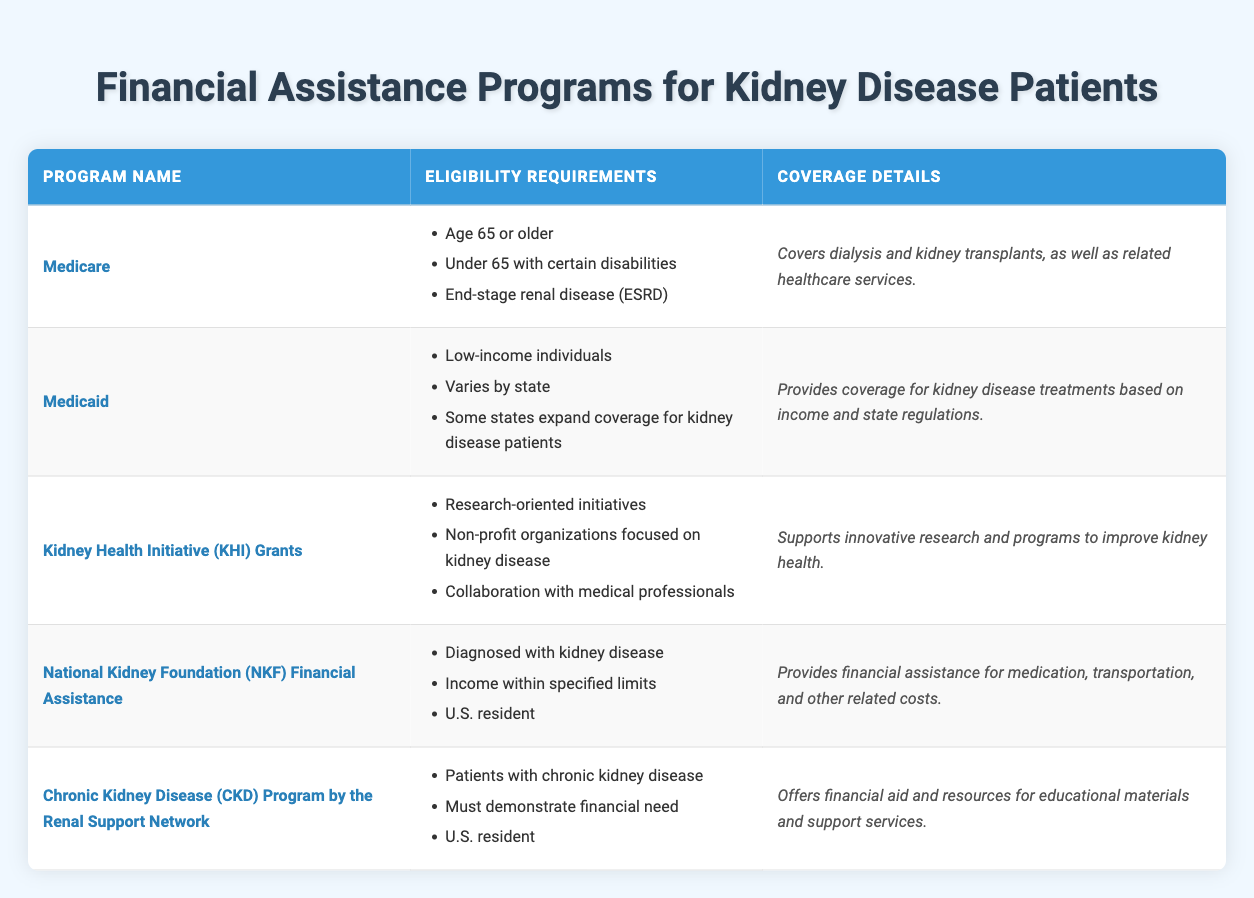What are the eligibility requirements for Medicare? The eligibility requirements for Medicare are listed in the table under the program "Medicare." They include: Age 65 or older, Under 65 with certain disabilities, and End-stage renal disease (ESRD).
Answer: Age 65 or older, Under 65 with certain disabilities, End-stage renal disease (ESRD) Which program provides coverage for low-income individuals? The program that provides coverage for low-income individuals is Medicaid, as specified in its eligibility requirements in the table.
Answer: Medicaid True or False: The National Kidney Foundation (NKF) Financial Assistance requires applicants to be U.S. residents. According to the NKF Financial Assistance eligibility requirements in the table, one of the criteria is that the applicant must be a U.S. resident. Therefore, the statement is true.
Answer: True How many programs are specifically aimed at kidney disease patients? By reviewing the table, the programs that are specifically aimed at kidney disease patients are Medicare, Medicaid, National Kidney Foundation (NKF) Financial Assistance, and Chronic Kidney Disease (CKD) Program by the Renal Support Network. This makes a total of four programs.
Answer: Four What coverage details does the Chronic Kidney Disease (CKD) Program provide? The coverage details provided in the table for the CKD Program by the Renal Support Network state that it offers financial aid and resources for educational materials and support services.
Answer: Offers financial aid and resources for educational materials and support services If a patient is under 65 years old and has kidney disease, which financial assistance programs could they potentially qualify for? A patient under 65 with kidney disease could potentially qualify for Medicare (if they have ESRD) and Medicaid (if they meet low-income requirements). Both programs have eligibility criteria that include these aspects based on the table.
Answer: Medicare, Medicaid What is the primary focus of the Kidney Health Initiative (KHI) Grants? The table indicates that the Kidney Health Initiative (KHI) Grants are aimed at supporting research-oriented initiatives and programs focused on improving kidney health.
Answer: Supporting research-oriented initiatives related to kidney health Are the eligibility requirements for Medicaid the same across all states? The table states that the eligibility requirements for Medicaid vary by state, which indicates that they are not the same across all states. Therefore, the answer is no.
Answer: No 